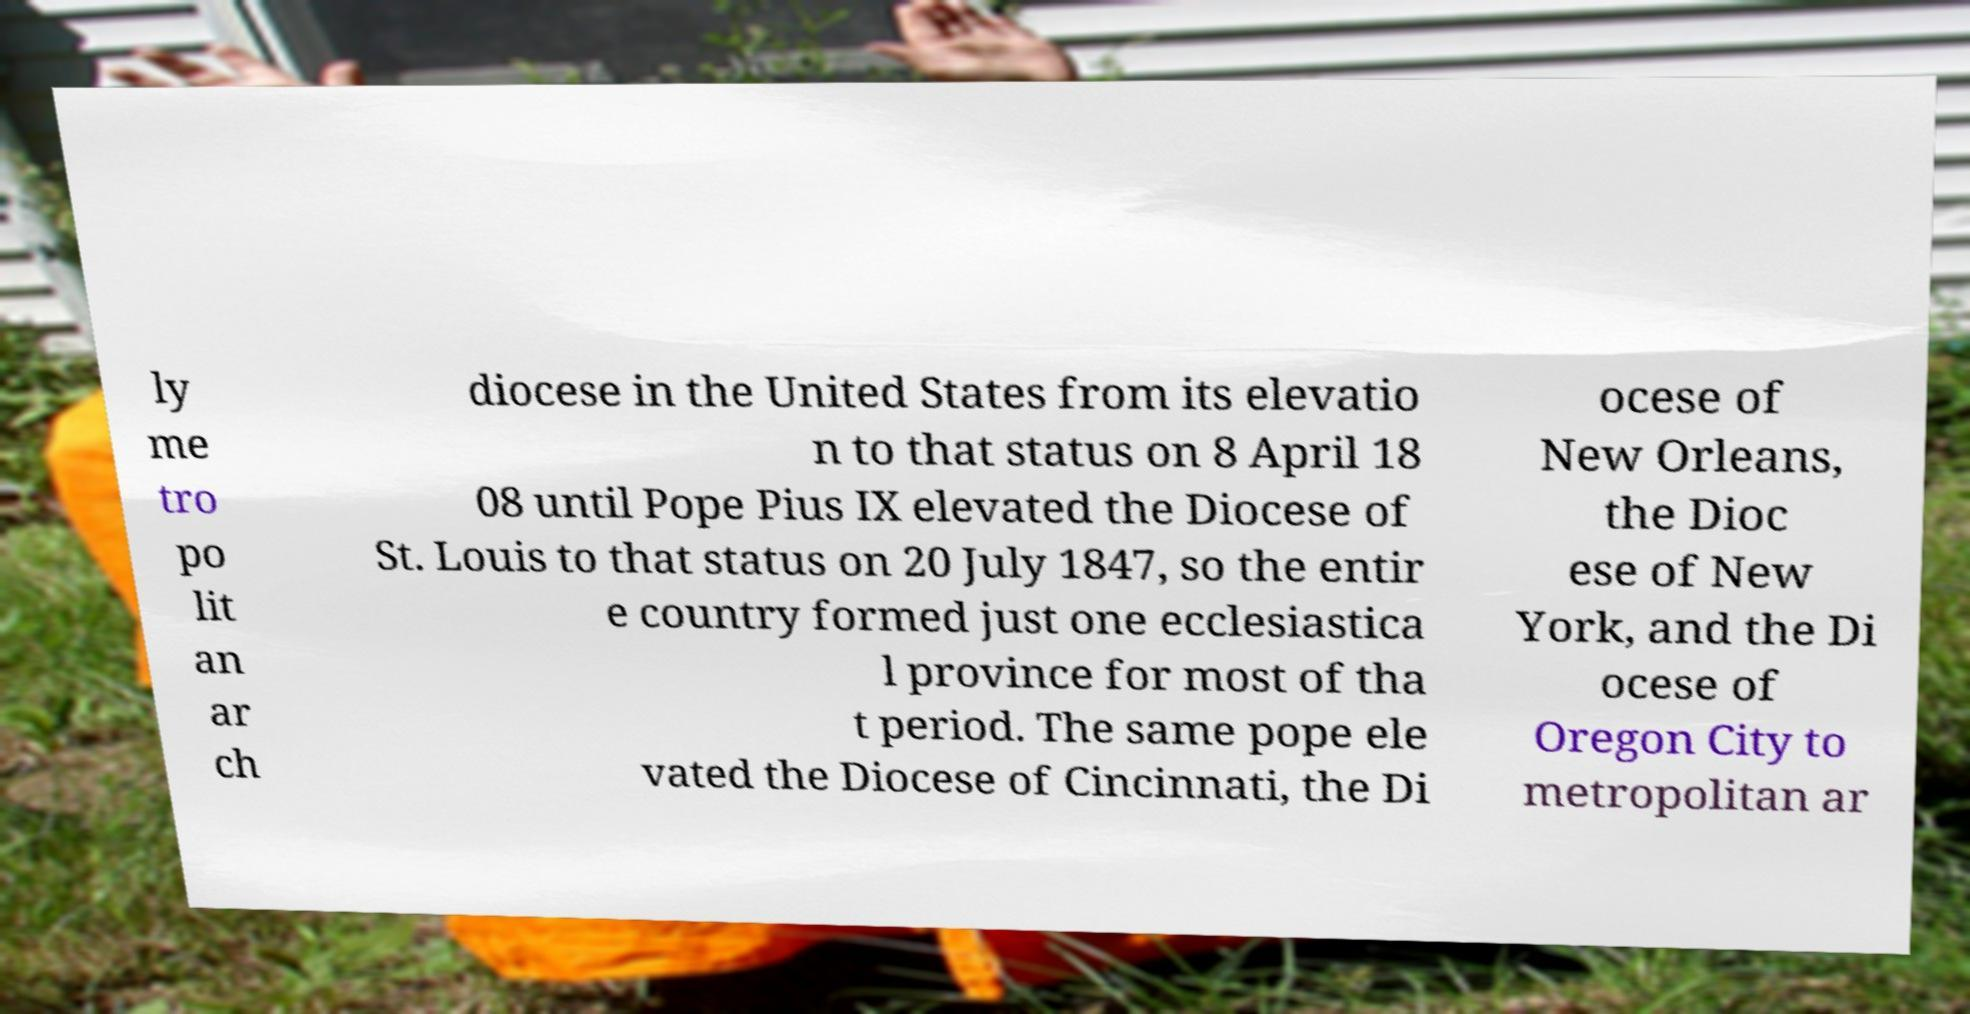Please read and relay the text visible in this image. What does it say? ly me tro po lit an ar ch diocese in the United States from its elevatio n to that status on 8 April 18 08 until Pope Pius IX elevated the Diocese of St. Louis to that status on 20 July 1847, so the entir e country formed just one ecclesiastica l province for most of tha t period. The same pope ele vated the Diocese of Cincinnati, the Di ocese of New Orleans, the Dioc ese of New York, and the Di ocese of Oregon City to metropolitan ar 